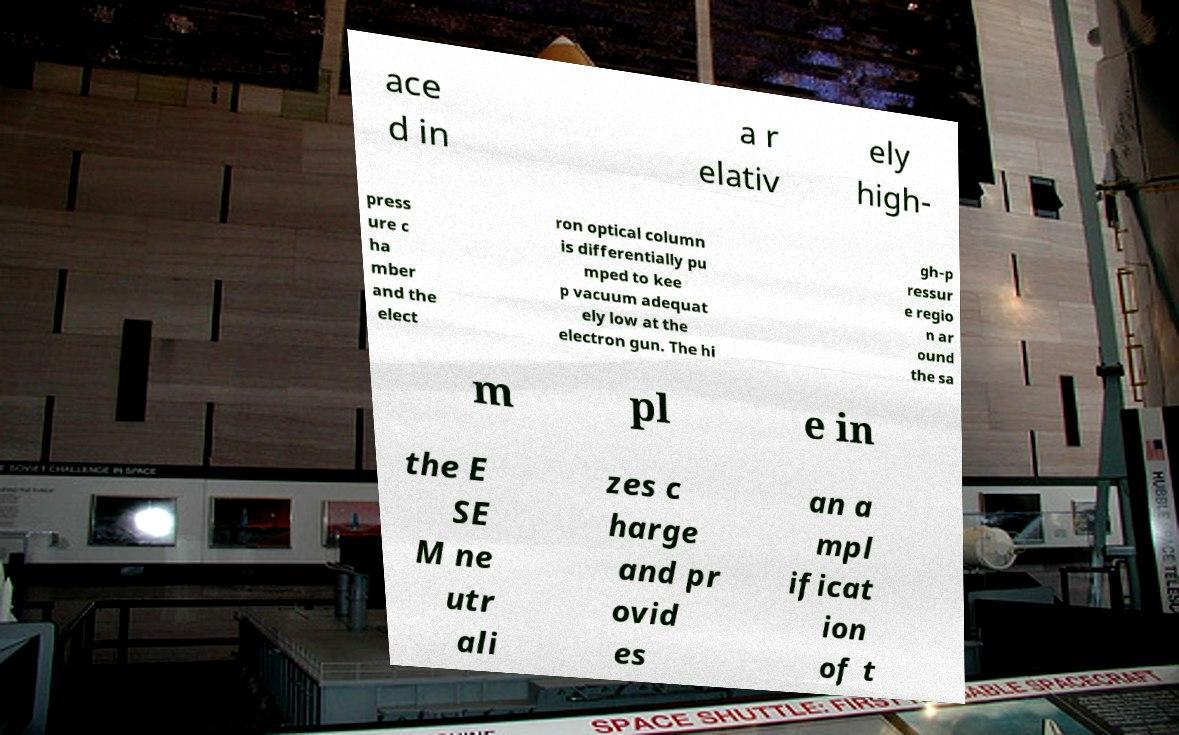I need the written content from this picture converted into text. Can you do that? ace d in a r elativ ely high- press ure c ha mber and the elect ron optical column is differentially pu mped to kee p vacuum adequat ely low at the electron gun. The hi gh-p ressur e regio n ar ound the sa m pl e in the E SE M ne utr ali zes c harge and pr ovid es an a mpl ificat ion of t 